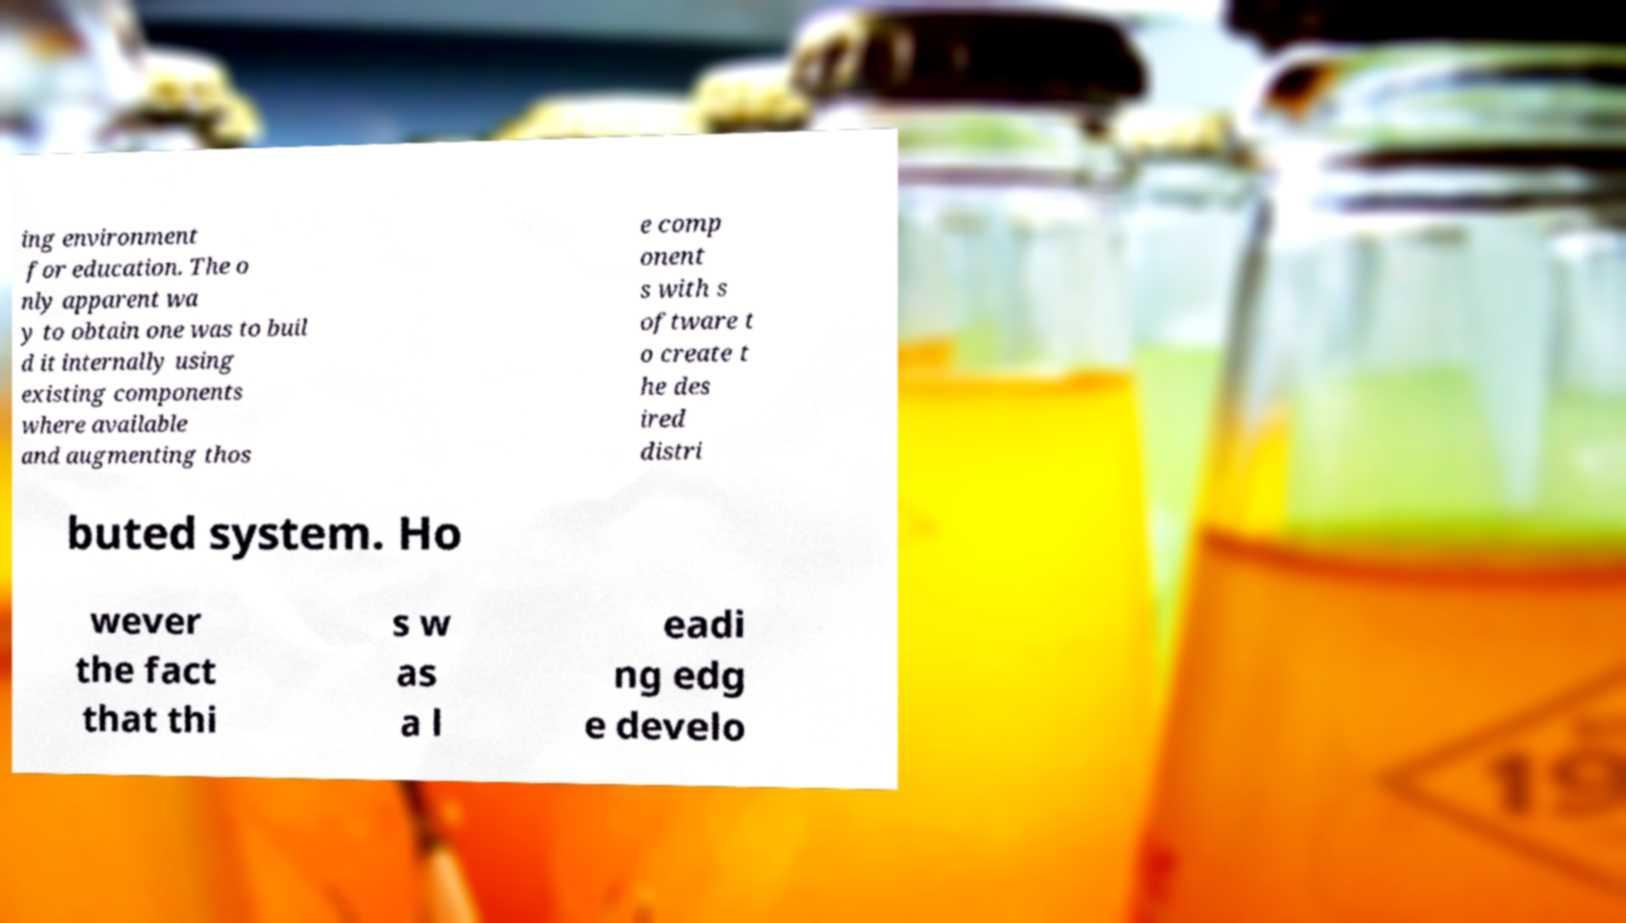Could you assist in decoding the text presented in this image and type it out clearly? ing environment for education. The o nly apparent wa y to obtain one was to buil d it internally using existing components where available and augmenting thos e comp onent s with s oftware t o create t he des ired distri buted system. Ho wever the fact that thi s w as a l eadi ng edg e develo 